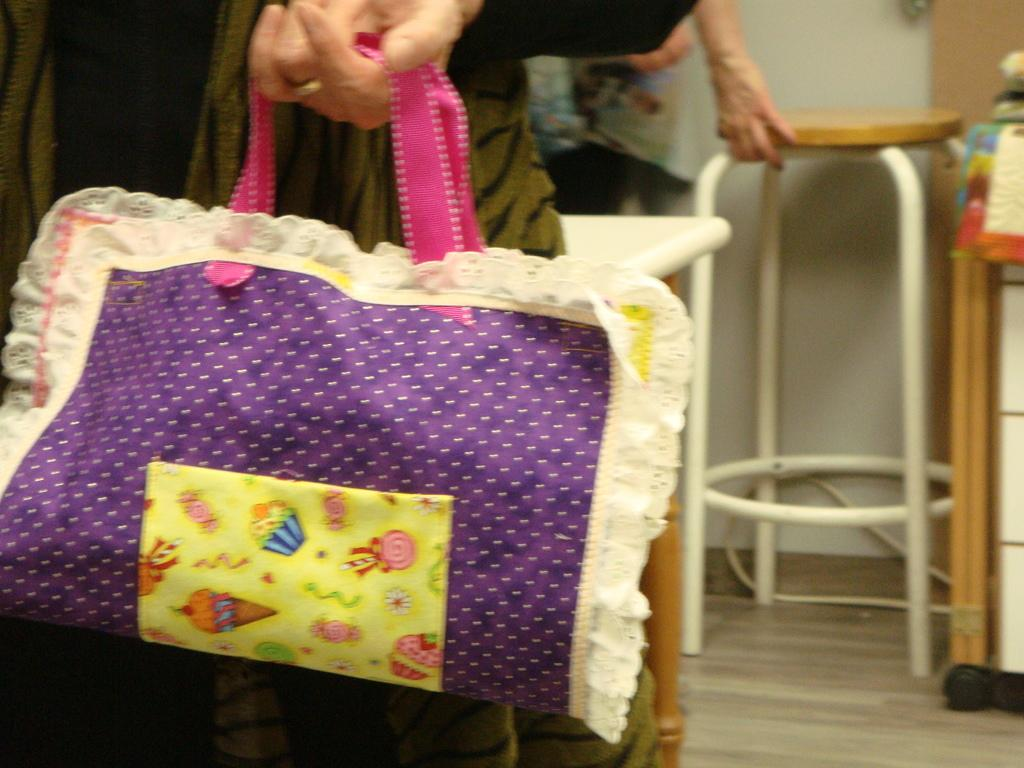What is the person on the left side of the image holding? The person on the left side of the image is holding a bag. What is the person on the right side of the image holding? The person on the right side of the image is holding a table. What type of curtain is hanging from the table in the image? There is no curtain present in the image. How many worms can be seen crawling on the bag in the image? There are no worms present in the image. 